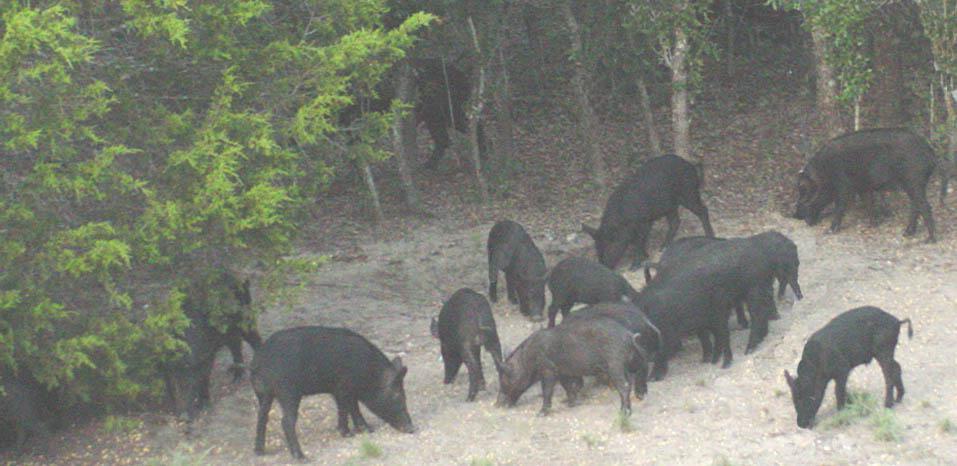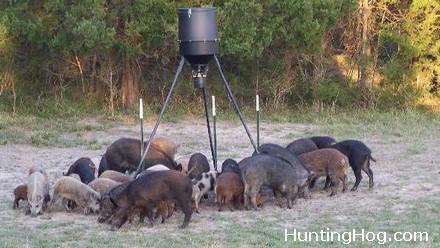The first image is the image on the left, the second image is the image on the right. Assess this claim about the two images: "There is a man made object in a field in one of the images.". Correct or not? Answer yes or no. Yes. The first image is the image on the left, the second image is the image on the right. For the images shown, is this caption "A group of hogs is garthered near a barrel-shaped feeder on a tripod." true? Answer yes or no. Yes. 